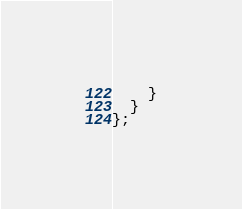<code> <loc_0><loc_0><loc_500><loc_500><_TypeScript_>    }
  }
};
</code> 